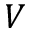<formula> <loc_0><loc_0><loc_500><loc_500>V</formula> 